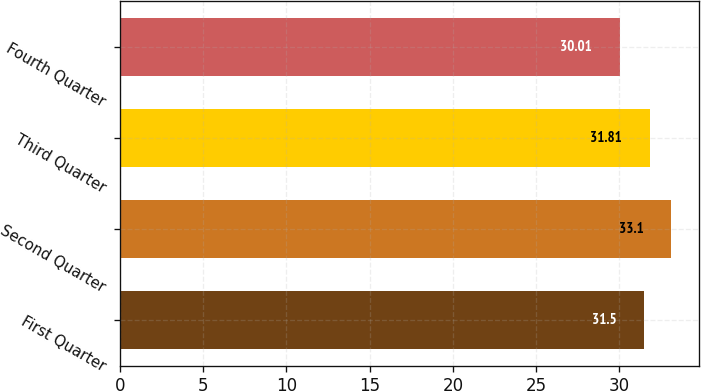<chart> <loc_0><loc_0><loc_500><loc_500><bar_chart><fcel>First Quarter<fcel>Second Quarter<fcel>Third Quarter<fcel>Fourth Quarter<nl><fcel>31.5<fcel>33.1<fcel>31.81<fcel>30.01<nl></chart> 